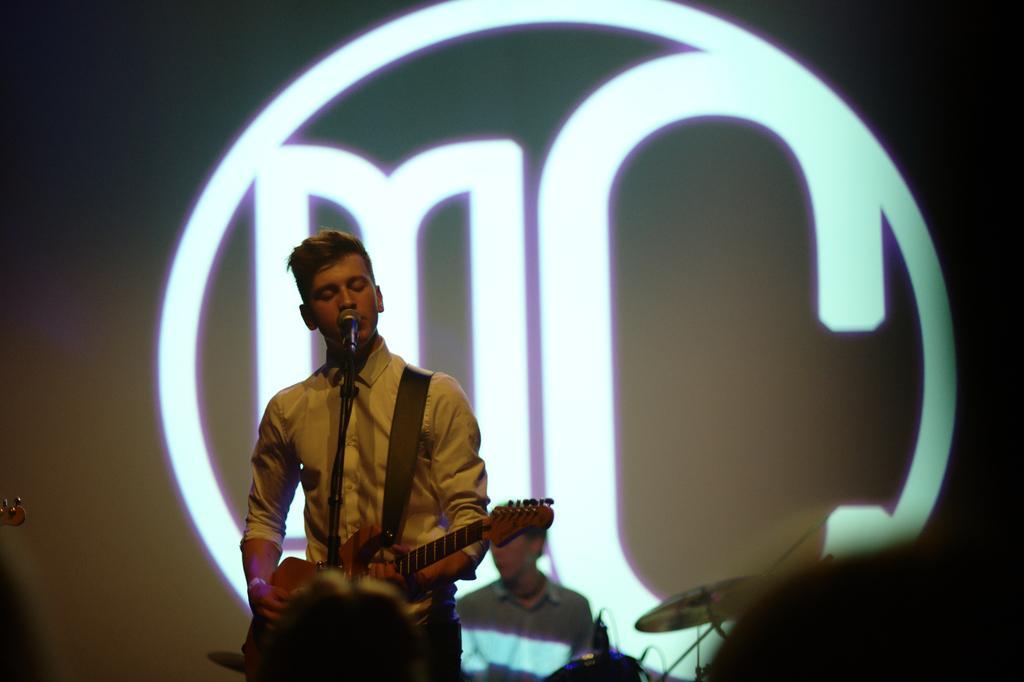Could you give a brief overview of what you see in this image? This Picture describe about a live performance of a boy wearing white shirt holding the guitar in this hand and singing in the microphone, behind a man wearing blue shirt is playing band, And on extreme behind, we can see the MC symbol is lighting up. 